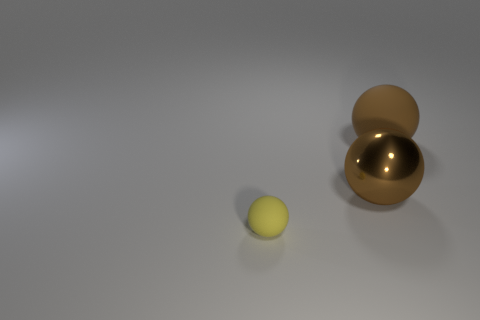There is a matte thing that is to the left of the big rubber thing; is it the same size as the matte sphere to the right of the small rubber sphere?
Give a very brief answer. No. There is a ball that is both in front of the big brown rubber object and behind the yellow thing; what is its material?
Provide a succinct answer. Metal. Is there anything else that has the same color as the big matte ball?
Offer a terse response. Yes. Is the number of metallic balls in front of the small ball less than the number of large brown metal balls?
Your response must be concise. Yes. Is the number of green shiny spheres greater than the number of large balls?
Keep it short and to the point. No. Are there any yellow matte spheres that are to the left of the matte ball left of the matte sphere behind the small ball?
Give a very brief answer. No. How many other things are the same size as the yellow rubber ball?
Your answer should be very brief. 0. There is a large brown metal ball; are there any yellow matte objects on the right side of it?
Offer a very short reply. No. There is a big matte object; is its color the same as the thing to the left of the big metallic thing?
Provide a short and direct response. No. There is a rubber ball that is right of the matte ball on the left side of the brown sphere left of the brown matte ball; what is its color?
Make the answer very short. Brown. 